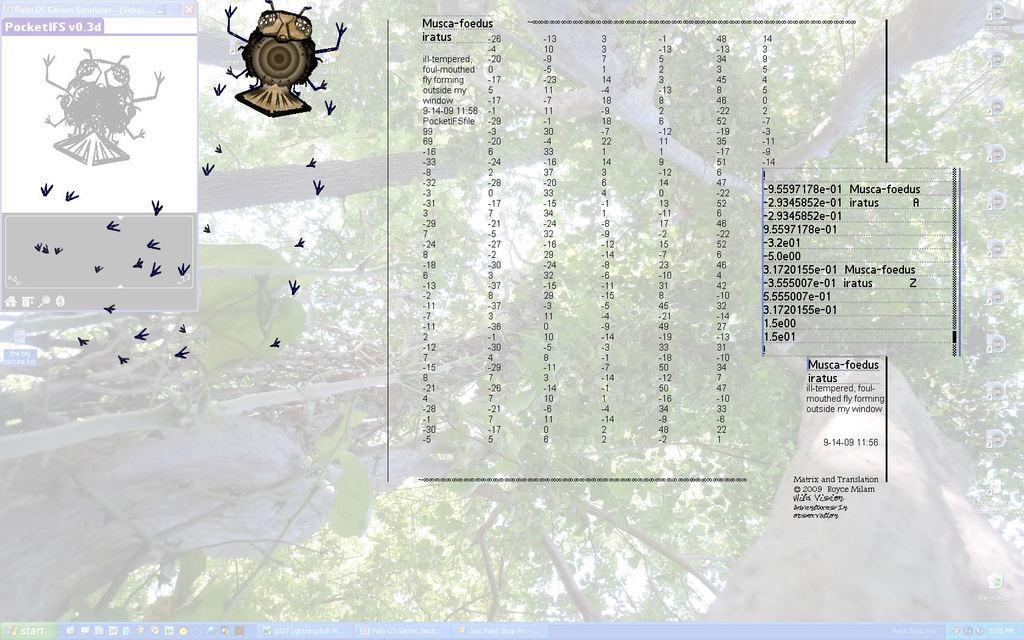Could you give a brief overview of what you see in this image? This image is of a monitor screen. At the bottom of the image there are some icons. There are trees. There is some text and there is a insect. 